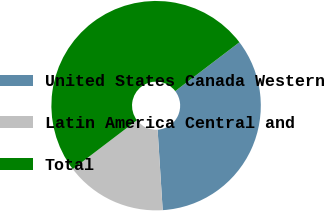Convert chart to OTSL. <chart><loc_0><loc_0><loc_500><loc_500><pie_chart><fcel>United States Canada Western<fcel>Latin America Central and<fcel>Total<nl><fcel>34.35%<fcel>15.65%<fcel>50.0%<nl></chart> 